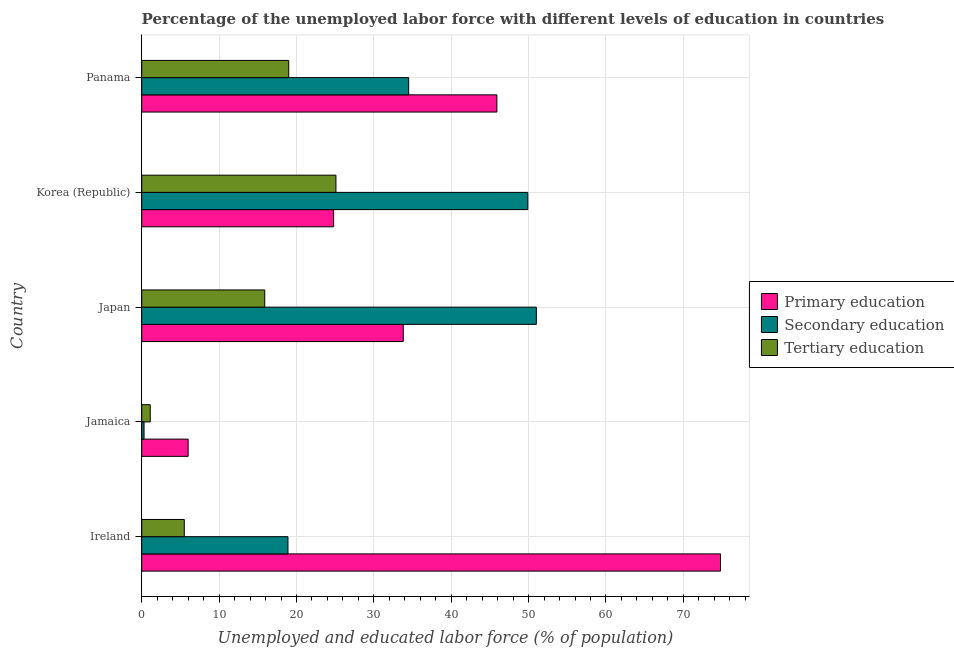How many different coloured bars are there?
Ensure brevity in your answer.  3. How many groups of bars are there?
Make the answer very short. 5. How many bars are there on the 4th tick from the bottom?
Offer a terse response. 3. What is the label of the 4th group of bars from the top?
Your answer should be compact. Jamaica. In how many cases, is the number of bars for a given country not equal to the number of legend labels?
Your response must be concise. 0. What is the percentage of labor force who received tertiary education in Japan?
Provide a succinct answer. 15.9. Across all countries, what is the minimum percentage of labor force who received primary education?
Ensure brevity in your answer.  6. In which country was the percentage of labor force who received primary education minimum?
Your answer should be very brief. Jamaica. What is the total percentage of labor force who received secondary education in the graph?
Your answer should be compact. 154.6. What is the difference between the percentage of labor force who received secondary education in Ireland and that in Panama?
Make the answer very short. -15.6. What is the difference between the percentage of labor force who received tertiary education in Japan and the percentage of labor force who received secondary education in Korea (Republic)?
Provide a short and direct response. -34. What is the average percentage of labor force who received secondary education per country?
Your answer should be compact. 30.92. What is the difference between the percentage of labor force who received secondary education and percentage of labor force who received primary education in Korea (Republic)?
Your answer should be compact. 25.1. In how many countries, is the percentage of labor force who received secondary education greater than 10 %?
Offer a very short reply. 4. What is the ratio of the percentage of labor force who received primary education in Ireland to that in Panama?
Ensure brevity in your answer.  1.63. Is the percentage of labor force who received tertiary education in Japan less than that in Panama?
Offer a terse response. Yes. What is the difference between the highest and the lowest percentage of labor force who received primary education?
Provide a succinct answer. 68.8. Is the sum of the percentage of labor force who received tertiary education in Jamaica and Korea (Republic) greater than the maximum percentage of labor force who received primary education across all countries?
Make the answer very short. No. What does the 2nd bar from the top in Ireland represents?
Ensure brevity in your answer.  Secondary education. What does the 1st bar from the bottom in Jamaica represents?
Your answer should be very brief. Primary education. How many bars are there?
Offer a terse response. 15. Are all the bars in the graph horizontal?
Your response must be concise. Yes. What is the difference between two consecutive major ticks on the X-axis?
Ensure brevity in your answer.  10. Does the graph contain any zero values?
Ensure brevity in your answer.  No. How many legend labels are there?
Offer a terse response. 3. What is the title of the graph?
Ensure brevity in your answer.  Percentage of the unemployed labor force with different levels of education in countries. What is the label or title of the X-axis?
Keep it short and to the point. Unemployed and educated labor force (% of population). What is the label or title of the Y-axis?
Provide a short and direct response. Country. What is the Unemployed and educated labor force (% of population) of Primary education in Ireland?
Offer a terse response. 74.8. What is the Unemployed and educated labor force (% of population) of Secondary education in Ireland?
Provide a succinct answer. 18.9. What is the Unemployed and educated labor force (% of population) in Primary education in Jamaica?
Offer a very short reply. 6. What is the Unemployed and educated labor force (% of population) of Secondary education in Jamaica?
Make the answer very short. 0.3. What is the Unemployed and educated labor force (% of population) of Tertiary education in Jamaica?
Offer a very short reply. 1.1. What is the Unemployed and educated labor force (% of population) in Primary education in Japan?
Your response must be concise. 33.8. What is the Unemployed and educated labor force (% of population) of Secondary education in Japan?
Make the answer very short. 51. What is the Unemployed and educated labor force (% of population) in Tertiary education in Japan?
Your answer should be compact. 15.9. What is the Unemployed and educated labor force (% of population) in Primary education in Korea (Republic)?
Offer a terse response. 24.8. What is the Unemployed and educated labor force (% of population) in Secondary education in Korea (Republic)?
Offer a very short reply. 49.9. What is the Unemployed and educated labor force (% of population) of Tertiary education in Korea (Republic)?
Offer a very short reply. 25.1. What is the Unemployed and educated labor force (% of population) of Primary education in Panama?
Your response must be concise. 45.9. What is the Unemployed and educated labor force (% of population) of Secondary education in Panama?
Your answer should be compact. 34.5. What is the Unemployed and educated labor force (% of population) in Tertiary education in Panama?
Your response must be concise. 19. Across all countries, what is the maximum Unemployed and educated labor force (% of population) in Primary education?
Your answer should be very brief. 74.8. Across all countries, what is the maximum Unemployed and educated labor force (% of population) of Tertiary education?
Your response must be concise. 25.1. Across all countries, what is the minimum Unemployed and educated labor force (% of population) in Primary education?
Offer a very short reply. 6. Across all countries, what is the minimum Unemployed and educated labor force (% of population) in Secondary education?
Ensure brevity in your answer.  0.3. Across all countries, what is the minimum Unemployed and educated labor force (% of population) of Tertiary education?
Keep it short and to the point. 1.1. What is the total Unemployed and educated labor force (% of population) of Primary education in the graph?
Your answer should be compact. 185.3. What is the total Unemployed and educated labor force (% of population) of Secondary education in the graph?
Ensure brevity in your answer.  154.6. What is the total Unemployed and educated labor force (% of population) in Tertiary education in the graph?
Provide a succinct answer. 66.6. What is the difference between the Unemployed and educated labor force (% of population) in Primary education in Ireland and that in Jamaica?
Make the answer very short. 68.8. What is the difference between the Unemployed and educated labor force (% of population) of Secondary education in Ireland and that in Japan?
Ensure brevity in your answer.  -32.1. What is the difference between the Unemployed and educated labor force (% of population) in Secondary education in Ireland and that in Korea (Republic)?
Offer a very short reply. -31. What is the difference between the Unemployed and educated labor force (% of population) in Tertiary education in Ireland and that in Korea (Republic)?
Provide a succinct answer. -19.6. What is the difference between the Unemployed and educated labor force (% of population) in Primary education in Ireland and that in Panama?
Provide a short and direct response. 28.9. What is the difference between the Unemployed and educated labor force (% of population) of Secondary education in Ireland and that in Panama?
Your answer should be compact. -15.6. What is the difference between the Unemployed and educated labor force (% of population) of Tertiary education in Ireland and that in Panama?
Offer a terse response. -13.5. What is the difference between the Unemployed and educated labor force (% of population) of Primary education in Jamaica and that in Japan?
Make the answer very short. -27.8. What is the difference between the Unemployed and educated labor force (% of population) in Secondary education in Jamaica and that in Japan?
Offer a very short reply. -50.7. What is the difference between the Unemployed and educated labor force (% of population) of Tertiary education in Jamaica and that in Japan?
Give a very brief answer. -14.8. What is the difference between the Unemployed and educated labor force (% of population) of Primary education in Jamaica and that in Korea (Republic)?
Ensure brevity in your answer.  -18.8. What is the difference between the Unemployed and educated labor force (% of population) in Secondary education in Jamaica and that in Korea (Republic)?
Ensure brevity in your answer.  -49.6. What is the difference between the Unemployed and educated labor force (% of population) of Primary education in Jamaica and that in Panama?
Make the answer very short. -39.9. What is the difference between the Unemployed and educated labor force (% of population) of Secondary education in Jamaica and that in Panama?
Offer a very short reply. -34.2. What is the difference between the Unemployed and educated labor force (% of population) in Tertiary education in Jamaica and that in Panama?
Keep it short and to the point. -17.9. What is the difference between the Unemployed and educated labor force (% of population) in Tertiary education in Japan and that in Korea (Republic)?
Provide a succinct answer. -9.2. What is the difference between the Unemployed and educated labor force (% of population) in Primary education in Japan and that in Panama?
Make the answer very short. -12.1. What is the difference between the Unemployed and educated labor force (% of population) of Secondary education in Japan and that in Panama?
Ensure brevity in your answer.  16.5. What is the difference between the Unemployed and educated labor force (% of population) of Tertiary education in Japan and that in Panama?
Your answer should be very brief. -3.1. What is the difference between the Unemployed and educated labor force (% of population) of Primary education in Korea (Republic) and that in Panama?
Your response must be concise. -21.1. What is the difference between the Unemployed and educated labor force (% of population) in Tertiary education in Korea (Republic) and that in Panama?
Make the answer very short. 6.1. What is the difference between the Unemployed and educated labor force (% of population) of Primary education in Ireland and the Unemployed and educated labor force (% of population) of Secondary education in Jamaica?
Your answer should be compact. 74.5. What is the difference between the Unemployed and educated labor force (% of population) in Primary education in Ireland and the Unemployed and educated labor force (% of population) in Tertiary education in Jamaica?
Offer a very short reply. 73.7. What is the difference between the Unemployed and educated labor force (% of population) of Secondary education in Ireland and the Unemployed and educated labor force (% of population) of Tertiary education in Jamaica?
Offer a very short reply. 17.8. What is the difference between the Unemployed and educated labor force (% of population) of Primary education in Ireland and the Unemployed and educated labor force (% of population) of Secondary education in Japan?
Ensure brevity in your answer.  23.8. What is the difference between the Unemployed and educated labor force (% of population) in Primary education in Ireland and the Unemployed and educated labor force (% of population) in Tertiary education in Japan?
Give a very brief answer. 58.9. What is the difference between the Unemployed and educated labor force (% of population) in Primary education in Ireland and the Unemployed and educated labor force (% of population) in Secondary education in Korea (Republic)?
Make the answer very short. 24.9. What is the difference between the Unemployed and educated labor force (% of population) of Primary education in Ireland and the Unemployed and educated labor force (% of population) of Tertiary education in Korea (Republic)?
Offer a terse response. 49.7. What is the difference between the Unemployed and educated labor force (% of population) in Secondary education in Ireland and the Unemployed and educated labor force (% of population) in Tertiary education in Korea (Republic)?
Make the answer very short. -6.2. What is the difference between the Unemployed and educated labor force (% of population) of Primary education in Ireland and the Unemployed and educated labor force (% of population) of Secondary education in Panama?
Provide a short and direct response. 40.3. What is the difference between the Unemployed and educated labor force (% of population) of Primary education in Ireland and the Unemployed and educated labor force (% of population) of Tertiary education in Panama?
Offer a terse response. 55.8. What is the difference between the Unemployed and educated labor force (% of population) in Secondary education in Ireland and the Unemployed and educated labor force (% of population) in Tertiary education in Panama?
Your response must be concise. -0.1. What is the difference between the Unemployed and educated labor force (% of population) of Primary education in Jamaica and the Unemployed and educated labor force (% of population) of Secondary education in Japan?
Keep it short and to the point. -45. What is the difference between the Unemployed and educated labor force (% of population) of Secondary education in Jamaica and the Unemployed and educated labor force (% of population) of Tertiary education in Japan?
Provide a short and direct response. -15.6. What is the difference between the Unemployed and educated labor force (% of population) of Primary education in Jamaica and the Unemployed and educated labor force (% of population) of Secondary education in Korea (Republic)?
Keep it short and to the point. -43.9. What is the difference between the Unemployed and educated labor force (% of population) in Primary education in Jamaica and the Unemployed and educated labor force (% of population) in Tertiary education in Korea (Republic)?
Your answer should be very brief. -19.1. What is the difference between the Unemployed and educated labor force (% of population) in Secondary education in Jamaica and the Unemployed and educated labor force (% of population) in Tertiary education in Korea (Republic)?
Ensure brevity in your answer.  -24.8. What is the difference between the Unemployed and educated labor force (% of population) in Primary education in Jamaica and the Unemployed and educated labor force (% of population) in Secondary education in Panama?
Provide a short and direct response. -28.5. What is the difference between the Unemployed and educated labor force (% of population) in Secondary education in Jamaica and the Unemployed and educated labor force (% of population) in Tertiary education in Panama?
Your answer should be very brief. -18.7. What is the difference between the Unemployed and educated labor force (% of population) in Primary education in Japan and the Unemployed and educated labor force (% of population) in Secondary education in Korea (Republic)?
Provide a succinct answer. -16.1. What is the difference between the Unemployed and educated labor force (% of population) in Primary education in Japan and the Unemployed and educated labor force (% of population) in Tertiary education in Korea (Republic)?
Provide a short and direct response. 8.7. What is the difference between the Unemployed and educated labor force (% of population) of Secondary education in Japan and the Unemployed and educated labor force (% of population) of Tertiary education in Korea (Republic)?
Offer a very short reply. 25.9. What is the difference between the Unemployed and educated labor force (% of population) of Primary education in Japan and the Unemployed and educated labor force (% of population) of Secondary education in Panama?
Your answer should be very brief. -0.7. What is the difference between the Unemployed and educated labor force (% of population) of Primary education in Japan and the Unemployed and educated labor force (% of population) of Tertiary education in Panama?
Give a very brief answer. 14.8. What is the difference between the Unemployed and educated labor force (% of population) of Secondary education in Japan and the Unemployed and educated labor force (% of population) of Tertiary education in Panama?
Make the answer very short. 32. What is the difference between the Unemployed and educated labor force (% of population) in Primary education in Korea (Republic) and the Unemployed and educated labor force (% of population) in Tertiary education in Panama?
Give a very brief answer. 5.8. What is the difference between the Unemployed and educated labor force (% of population) in Secondary education in Korea (Republic) and the Unemployed and educated labor force (% of population) in Tertiary education in Panama?
Ensure brevity in your answer.  30.9. What is the average Unemployed and educated labor force (% of population) of Primary education per country?
Ensure brevity in your answer.  37.06. What is the average Unemployed and educated labor force (% of population) of Secondary education per country?
Ensure brevity in your answer.  30.92. What is the average Unemployed and educated labor force (% of population) of Tertiary education per country?
Keep it short and to the point. 13.32. What is the difference between the Unemployed and educated labor force (% of population) of Primary education and Unemployed and educated labor force (% of population) of Secondary education in Ireland?
Your answer should be compact. 55.9. What is the difference between the Unemployed and educated labor force (% of population) in Primary education and Unemployed and educated labor force (% of population) in Tertiary education in Ireland?
Ensure brevity in your answer.  69.3. What is the difference between the Unemployed and educated labor force (% of population) of Secondary education and Unemployed and educated labor force (% of population) of Tertiary education in Ireland?
Your response must be concise. 13.4. What is the difference between the Unemployed and educated labor force (% of population) of Primary education and Unemployed and educated labor force (% of population) of Secondary education in Jamaica?
Provide a succinct answer. 5.7. What is the difference between the Unemployed and educated labor force (% of population) of Primary education and Unemployed and educated labor force (% of population) of Tertiary education in Jamaica?
Offer a very short reply. 4.9. What is the difference between the Unemployed and educated labor force (% of population) of Primary education and Unemployed and educated labor force (% of population) of Secondary education in Japan?
Provide a succinct answer. -17.2. What is the difference between the Unemployed and educated labor force (% of population) in Primary education and Unemployed and educated labor force (% of population) in Tertiary education in Japan?
Ensure brevity in your answer.  17.9. What is the difference between the Unemployed and educated labor force (% of population) in Secondary education and Unemployed and educated labor force (% of population) in Tertiary education in Japan?
Keep it short and to the point. 35.1. What is the difference between the Unemployed and educated labor force (% of population) of Primary education and Unemployed and educated labor force (% of population) of Secondary education in Korea (Republic)?
Provide a short and direct response. -25.1. What is the difference between the Unemployed and educated labor force (% of population) in Secondary education and Unemployed and educated labor force (% of population) in Tertiary education in Korea (Republic)?
Provide a short and direct response. 24.8. What is the difference between the Unemployed and educated labor force (% of population) of Primary education and Unemployed and educated labor force (% of population) of Secondary education in Panama?
Your answer should be compact. 11.4. What is the difference between the Unemployed and educated labor force (% of population) in Primary education and Unemployed and educated labor force (% of population) in Tertiary education in Panama?
Keep it short and to the point. 26.9. What is the ratio of the Unemployed and educated labor force (% of population) of Primary education in Ireland to that in Jamaica?
Offer a very short reply. 12.47. What is the ratio of the Unemployed and educated labor force (% of population) in Tertiary education in Ireland to that in Jamaica?
Ensure brevity in your answer.  5. What is the ratio of the Unemployed and educated labor force (% of population) in Primary education in Ireland to that in Japan?
Make the answer very short. 2.21. What is the ratio of the Unemployed and educated labor force (% of population) of Secondary education in Ireland to that in Japan?
Provide a short and direct response. 0.37. What is the ratio of the Unemployed and educated labor force (% of population) in Tertiary education in Ireland to that in Japan?
Offer a very short reply. 0.35. What is the ratio of the Unemployed and educated labor force (% of population) in Primary education in Ireland to that in Korea (Republic)?
Provide a short and direct response. 3.02. What is the ratio of the Unemployed and educated labor force (% of population) in Secondary education in Ireland to that in Korea (Republic)?
Provide a succinct answer. 0.38. What is the ratio of the Unemployed and educated labor force (% of population) in Tertiary education in Ireland to that in Korea (Republic)?
Keep it short and to the point. 0.22. What is the ratio of the Unemployed and educated labor force (% of population) of Primary education in Ireland to that in Panama?
Provide a short and direct response. 1.63. What is the ratio of the Unemployed and educated labor force (% of population) in Secondary education in Ireland to that in Panama?
Offer a terse response. 0.55. What is the ratio of the Unemployed and educated labor force (% of population) in Tertiary education in Ireland to that in Panama?
Keep it short and to the point. 0.29. What is the ratio of the Unemployed and educated labor force (% of population) in Primary education in Jamaica to that in Japan?
Provide a short and direct response. 0.18. What is the ratio of the Unemployed and educated labor force (% of population) in Secondary education in Jamaica to that in Japan?
Provide a short and direct response. 0.01. What is the ratio of the Unemployed and educated labor force (% of population) in Tertiary education in Jamaica to that in Japan?
Give a very brief answer. 0.07. What is the ratio of the Unemployed and educated labor force (% of population) in Primary education in Jamaica to that in Korea (Republic)?
Offer a terse response. 0.24. What is the ratio of the Unemployed and educated labor force (% of population) in Secondary education in Jamaica to that in Korea (Republic)?
Provide a succinct answer. 0.01. What is the ratio of the Unemployed and educated labor force (% of population) of Tertiary education in Jamaica to that in Korea (Republic)?
Your response must be concise. 0.04. What is the ratio of the Unemployed and educated labor force (% of population) in Primary education in Jamaica to that in Panama?
Ensure brevity in your answer.  0.13. What is the ratio of the Unemployed and educated labor force (% of population) in Secondary education in Jamaica to that in Panama?
Provide a short and direct response. 0.01. What is the ratio of the Unemployed and educated labor force (% of population) of Tertiary education in Jamaica to that in Panama?
Ensure brevity in your answer.  0.06. What is the ratio of the Unemployed and educated labor force (% of population) of Primary education in Japan to that in Korea (Republic)?
Your answer should be compact. 1.36. What is the ratio of the Unemployed and educated labor force (% of population) of Tertiary education in Japan to that in Korea (Republic)?
Keep it short and to the point. 0.63. What is the ratio of the Unemployed and educated labor force (% of population) in Primary education in Japan to that in Panama?
Make the answer very short. 0.74. What is the ratio of the Unemployed and educated labor force (% of population) of Secondary education in Japan to that in Panama?
Offer a terse response. 1.48. What is the ratio of the Unemployed and educated labor force (% of population) in Tertiary education in Japan to that in Panama?
Keep it short and to the point. 0.84. What is the ratio of the Unemployed and educated labor force (% of population) of Primary education in Korea (Republic) to that in Panama?
Your answer should be compact. 0.54. What is the ratio of the Unemployed and educated labor force (% of population) in Secondary education in Korea (Republic) to that in Panama?
Provide a short and direct response. 1.45. What is the ratio of the Unemployed and educated labor force (% of population) of Tertiary education in Korea (Republic) to that in Panama?
Give a very brief answer. 1.32. What is the difference between the highest and the second highest Unemployed and educated labor force (% of population) in Primary education?
Give a very brief answer. 28.9. What is the difference between the highest and the second highest Unemployed and educated labor force (% of population) of Tertiary education?
Your answer should be very brief. 6.1. What is the difference between the highest and the lowest Unemployed and educated labor force (% of population) in Primary education?
Provide a short and direct response. 68.8. What is the difference between the highest and the lowest Unemployed and educated labor force (% of population) in Secondary education?
Ensure brevity in your answer.  50.7. 